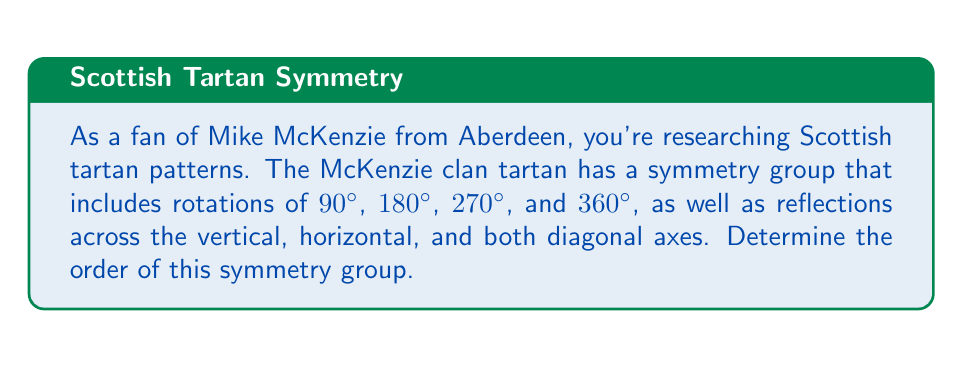Can you answer this question? To determine the order of the symmetry group, we need to count the number of distinct symmetry operations:

1. Rotations:
   - 90° rotation (counterclockwise)
   - 180° rotation
   - 270° rotation (equivalent to -90°)
   - 360° rotation (identity)

2. Reflections:
   - Vertical axis reflection
   - Horizontal axis reflection
   - Diagonal axis reflection (top-left to bottom-right)
   - Diagonal axis reflection (top-right to bottom-left)

The symmetry group of the McKenzie clan tartan pattern is isomorphic to the dihedral group $D_4$, which is the symmetry group of a square.

The order of a group is the number of elements in the group. In this case:

$$|D_4| = \text{number of rotations} + \text{number of reflections}$$
$$|D_4| = 4 + 4 = 8$$

Therefore, the order of the symmetry group for the McKenzie clan tartan pattern is 8.

This group can be represented mathematically as:

$$D_4 = \{e, r, r^2, r^3, s, sr, sr^2, sr^3\}$$

Where:
- $e$ is the identity operation
- $r$ is a 90° rotation
- $s$ is a reflection

The group multiplication table for $D_4$ would be an 8x8 table, showing how these elements combine under the group operation.
Answer: The order of the symmetry group for the McKenzie clan tartan pattern is 8. 